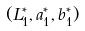Convert formula to latex. <formula><loc_0><loc_0><loc_500><loc_500>( L _ { 1 } ^ { * } , a _ { 1 } ^ { * } , b _ { 1 } ^ { * } )</formula> 